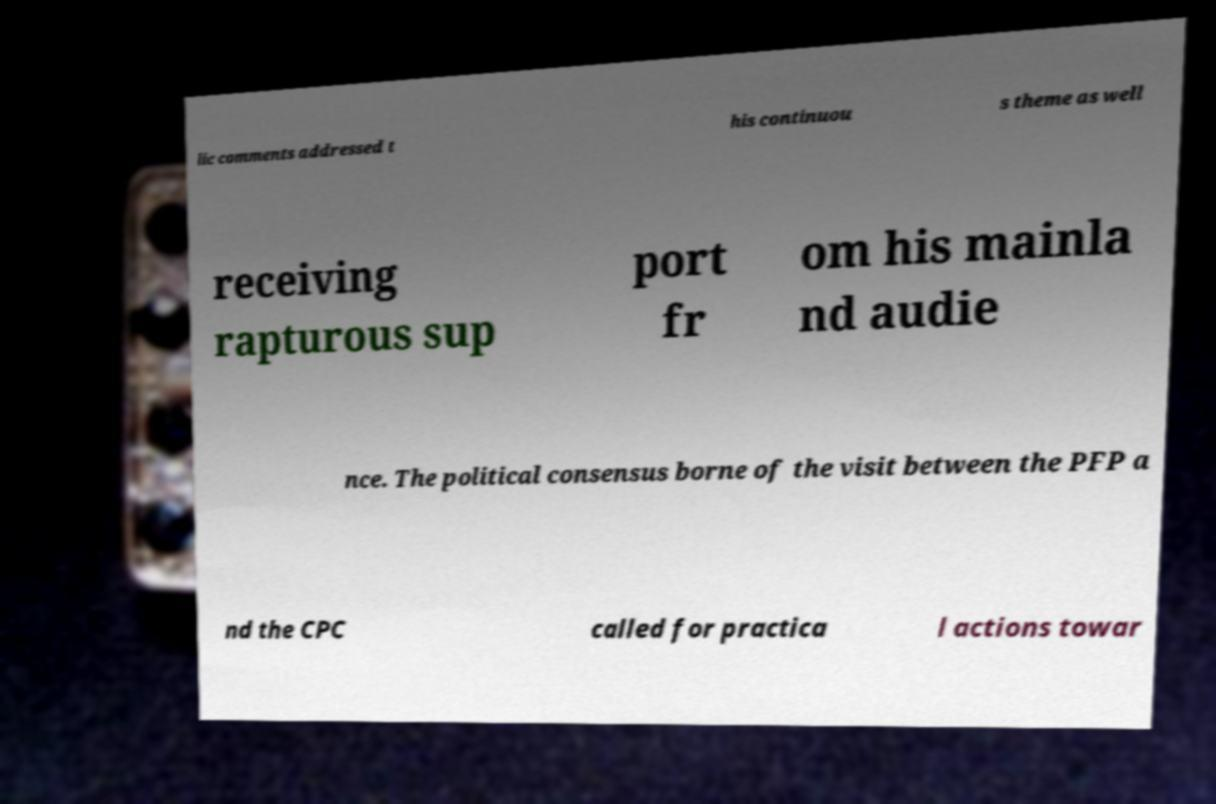Could you extract and type out the text from this image? lic comments addressed t his continuou s theme as well receiving rapturous sup port fr om his mainla nd audie nce. The political consensus borne of the visit between the PFP a nd the CPC called for practica l actions towar 